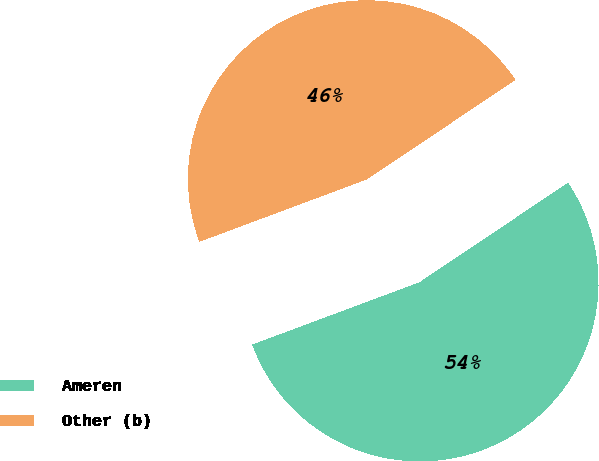<chart> <loc_0><loc_0><loc_500><loc_500><pie_chart><fcel>Ameren<fcel>Other (b)<nl><fcel>53.72%<fcel>46.28%<nl></chart> 